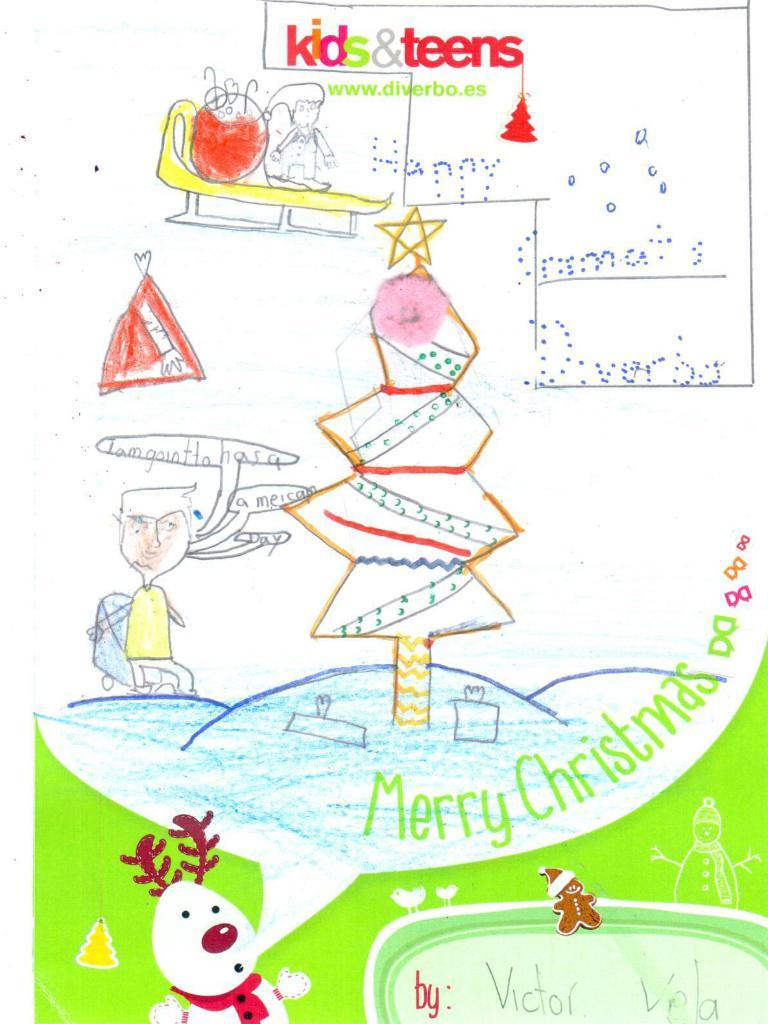What is the main subject of the drawing in the image? The drawing contains two people, a snowman, and a tree. Can you describe the setting of the drawing? The drawing contains a snowman and a tree, which suggests a winter or snowy setting. What else is present in the drawing besides the people and the snowman? The drawing contains some objects and some text. What type of yam is being protested in the image? There is no protest or yam present in the image; it is a drawing containing two people, a snowman, a tree, objects, and text. 